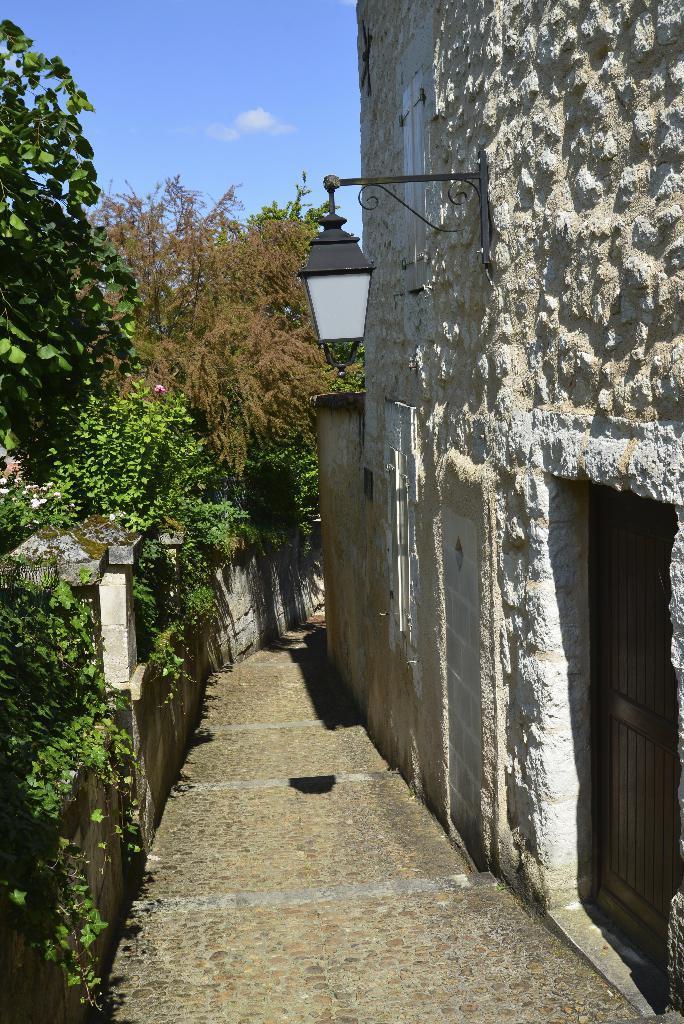Describe this image in one or two sentences. In this image we can see trees and the wall. On the right side of the image there is a wall, light and a door. On the left side of the image there are trees, wall and other objects. At the top of the image there is the sky. At the bottom of the image there is the floor. 